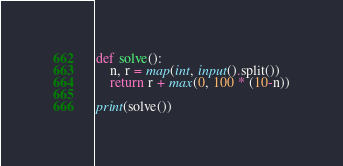Convert code to text. <code><loc_0><loc_0><loc_500><loc_500><_Python_>def solve():
    n, r = map(int, input().split())
    return r + max(0, 100 * (10-n))

print(solve())</code> 